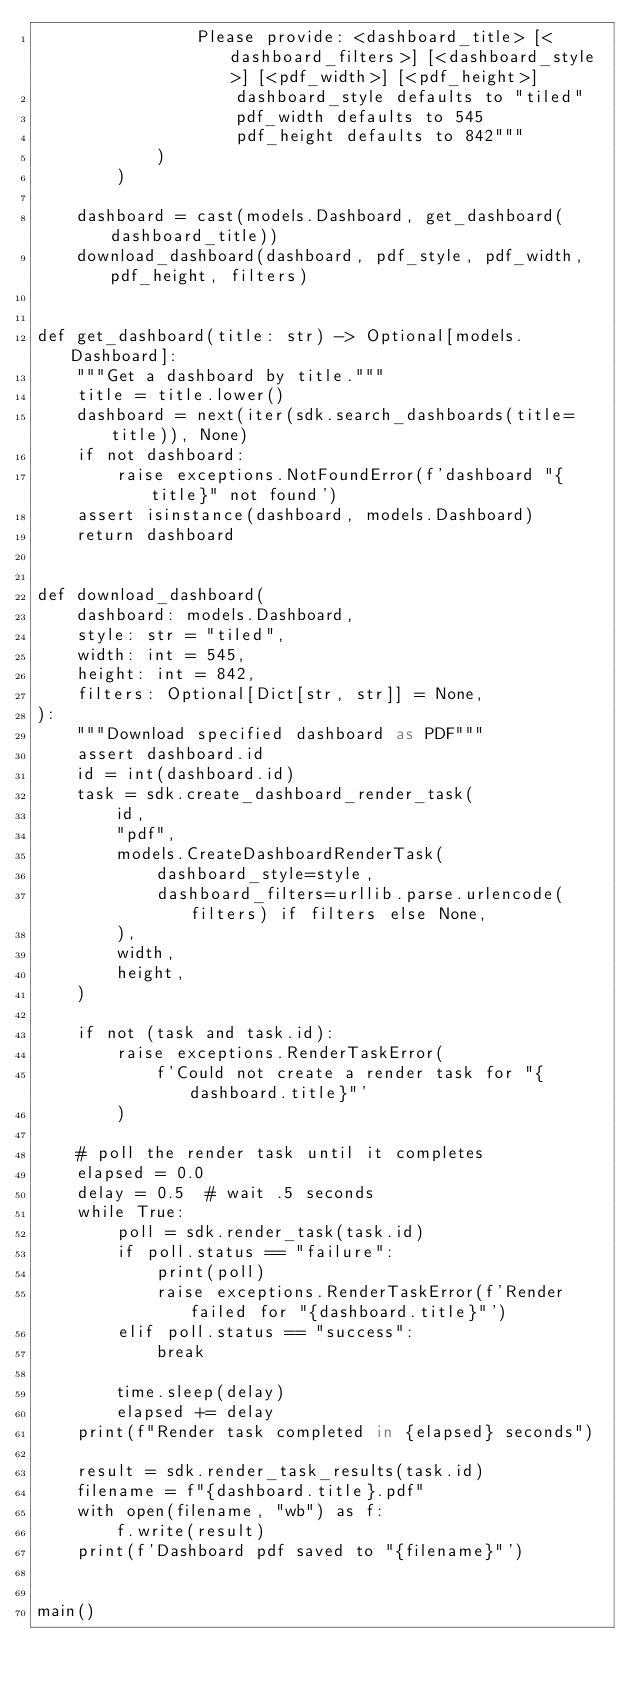<code> <loc_0><loc_0><loc_500><loc_500><_Python_>                Please provide: <dashboard_title> [<dashboard_filters>] [<dashboard_style>] [<pdf_width>] [<pdf_height>]
                    dashboard_style defaults to "tiled"
                    pdf_width defaults to 545
                    pdf_height defaults to 842"""
            )
        )

    dashboard = cast(models.Dashboard, get_dashboard(dashboard_title))
    download_dashboard(dashboard, pdf_style, pdf_width, pdf_height, filters)


def get_dashboard(title: str) -> Optional[models.Dashboard]:
    """Get a dashboard by title."""
    title = title.lower()
    dashboard = next(iter(sdk.search_dashboards(title=title)), None)
    if not dashboard:
        raise exceptions.NotFoundError(f'dashboard "{title}" not found')
    assert isinstance(dashboard, models.Dashboard)
    return dashboard


def download_dashboard(
    dashboard: models.Dashboard,
    style: str = "tiled",
    width: int = 545,
    height: int = 842,
    filters: Optional[Dict[str, str]] = None,
):
    """Download specified dashboard as PDF"""
    assert dashboard.id
    id = int(dashboard.id)
    task = sdk.create_dashboard_render_task(
        id,
        "pdf",
        models.CreateDashboardRenderTask(
            dashboard_style=style,
            dashboard_filters=urllib.parse.urlencode(filters) if filters else None,
        ),
        width,
        height,
    )

    if not (task and task.id):
        raise exceptions.RenderTaskError(
            f'Could not create a render task for "{dashboard.title}"'
        )

    # poll the render task until it completes
    elapsed = 0.0
    delay = 0.5  # wait .5 seconds
    while True:
        poll = sdk.render_task(task.id)
        if poll.status == "failure":
            print(poll)
            raise exceptions.RenderTaskError(f'Render failed for "{dashboard.title}"')
        elif poll.status == "success":
            break

        time.sleep(delay)
        elapsed += delay
    print(f"Render task completed in {elapsed} seconds")

    result = sdk.render_task_results(task.id)
    filename = f"{dashboard.title}.pdf"
    with open(filename, "wb") as f:
        f.write(result)
    print(f'Dashboard pdf saved to "{filename}"')


main()
</code> 